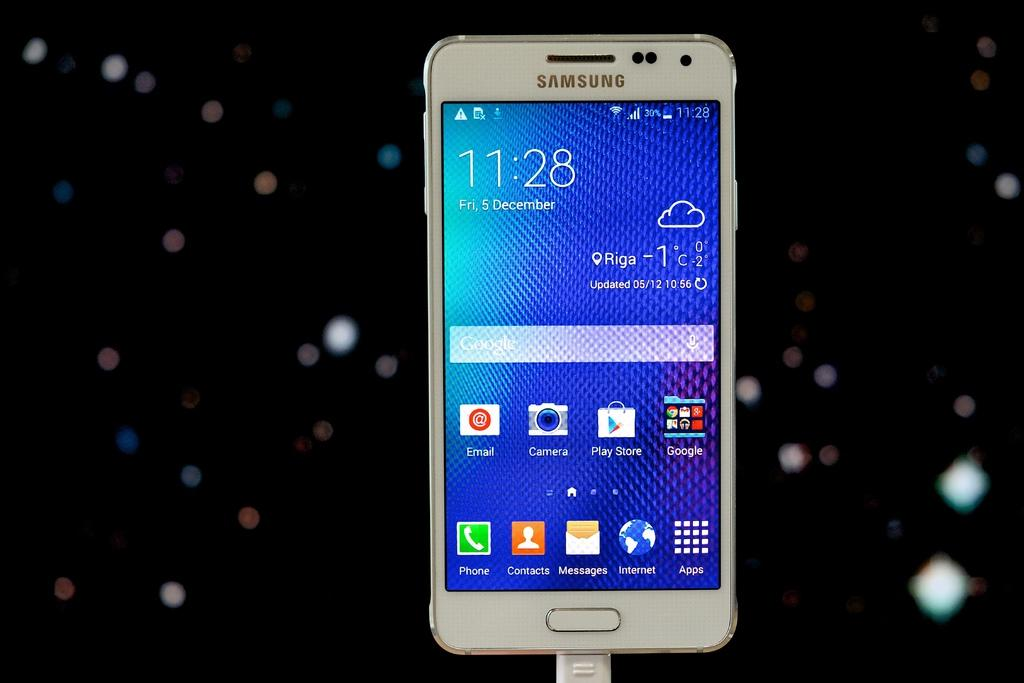<image>
Share a concise interpretation of the image provided. Samsung smartphone that says 11:28, Friday December 5th on it with apps on the home page. 